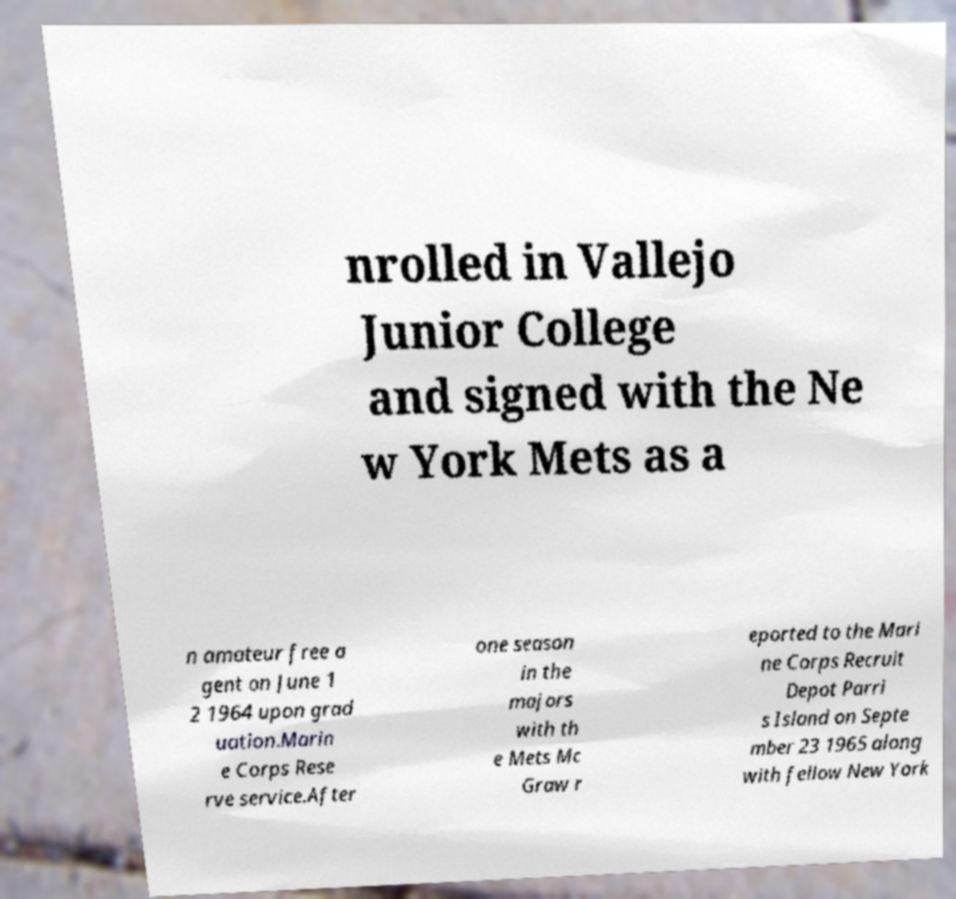What messages or text are displayed in this image? I need them in a readable, typed format. nrolled in Vallejo Junior College and signed with the Ne w York Mets as a n amateur free a gent on June 1 2 1964 upon grad uation.Marin e Corps Rese rve service.After one season in the majors with th e Mets Mc Graw r eported to the Mari ne Corps Recruit Depot Parri s Island on Septe mber 23 1965 along with fellow New York 